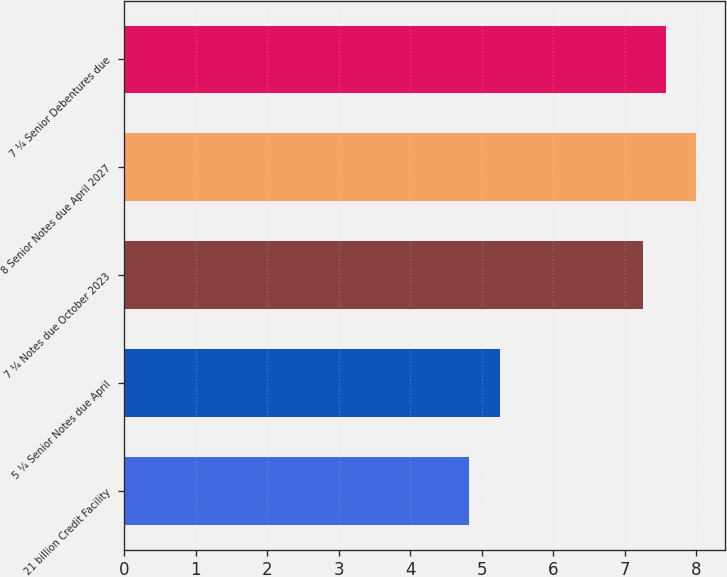Convert chart to OTSL. <chart><loc_0><loc_0><loc_500><loc_500><bar_chart><fcel>21 billion Credit Facility<fcel>5 ¼ Senior Notes due April<fcel>7 ¼ Notes due October 2023<fcel>8 Senior Notes due April 2027<fcel>7 ¼ Senior Debentures due<nl><fcel>4.82<fcel>5.25<fcel>7.25<fcel>8<fcel>7.57<nl></chart> 